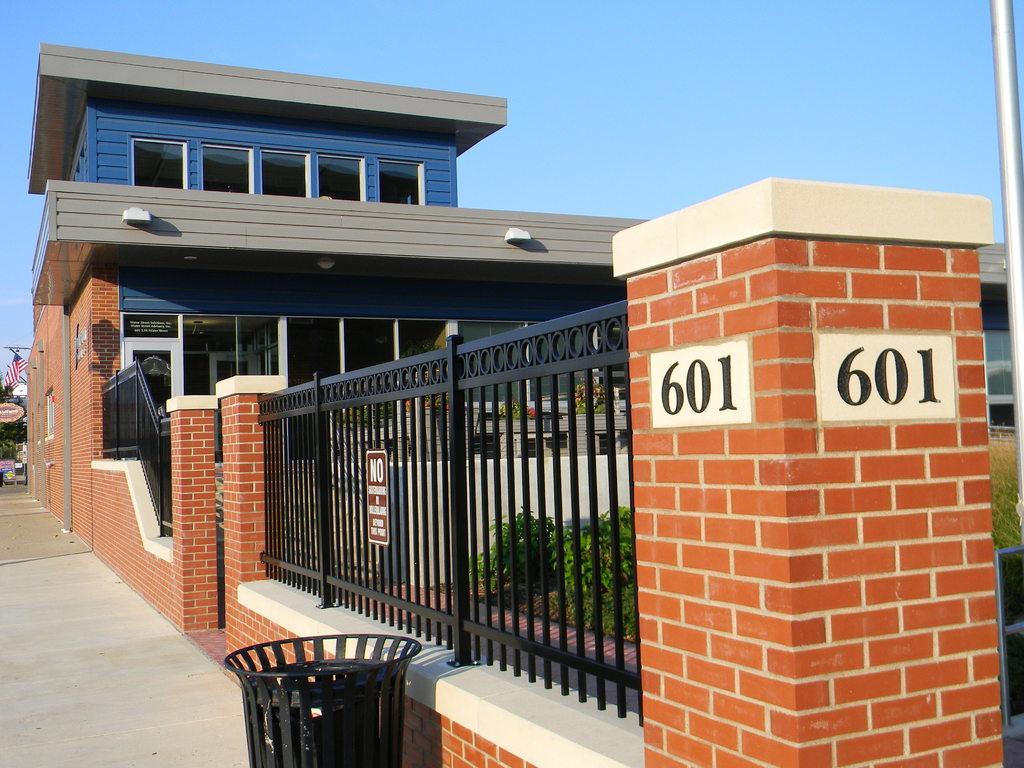How would you summarize this image in a sentence or two? On the left side, there is a footpath on which there is a dustbin. On the right side, there is a wall. In the background, there is a building having windows, there are plants, trees and the sky. 